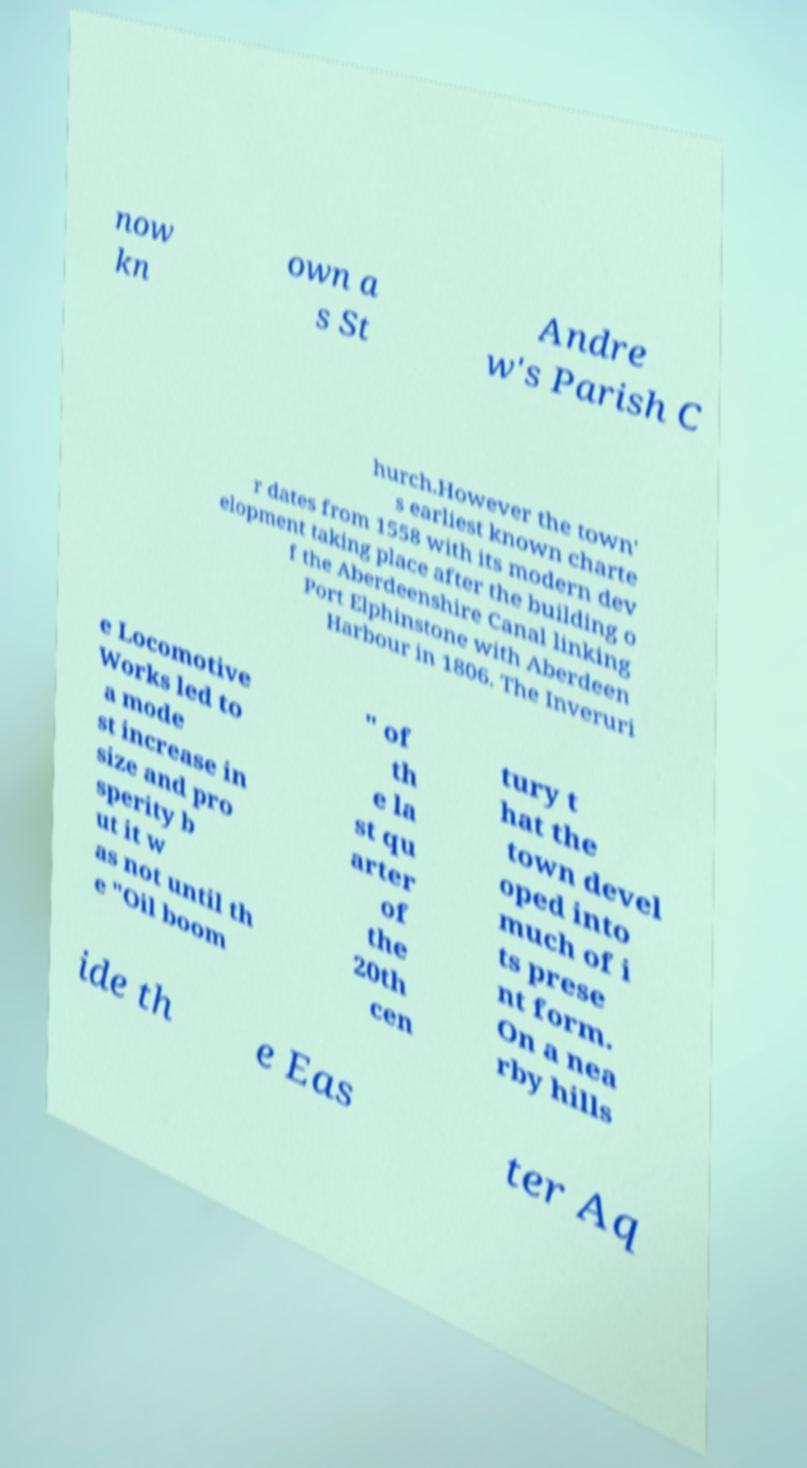There's text embedded in this image that I need extracted. Can you transcribe it verbatim? now kn own a s St Andre w's Parish C hurch.However the town' s earliest known charte r dates from 1558 with its modern dev elopment taking place after the building o f the Aberdeenshire Canal linking Port Elphinstone with Aberdeen Harbour in 1806. The Inveruri e Locomotive Works led to a mode st increase in size and pro sperity b ut it w as not until th e "Oil boom " of th e la st qu arter of the 20th cen tury t hat the town devel oped into much of i ts prese nt form. On a nea rby hills ide th e Eas ter Aq 